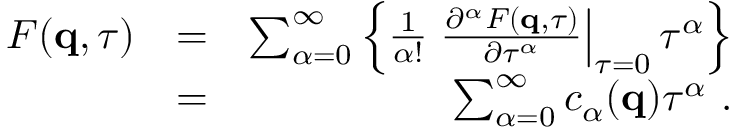Convert formula to latex. <formula><loc_0><loc_0><loc_500><loc_500>\begin{array} { r l r } { F ( q , \tau ) } & { = } & { \sum _ { \alpha = 0 } ^ { \infty } \left \{ \frac { 1 } { \alpha ! } \frac { \partial ^ { \alpha } F ( q , \tau ) } { \partial \tau ^ { \alpha } } \right | _ { \tau = 0 } \tau ^ { \alpha } \right \} } \\ & { = } & { \sum _ { \alpha = 0 } ^ { \infty } c _ { \alpha } ( q ) \tau ^ { \alpha } \ . } \end{array}</formula> 